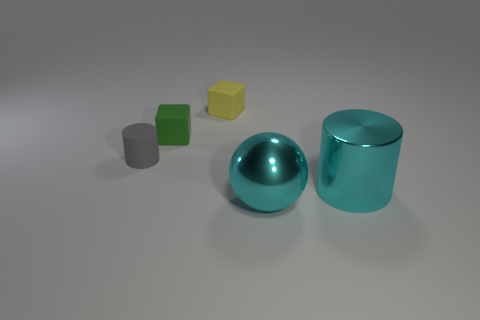Add 3 small cyan metallic objects. How many objects exist? 8 Subtract all cubes. How many objects are left? 3 Add 3 yellow blocks. How many yellow blocks exist? 4 Subtract 0 gray cubes. How many objects are left? 5 Subtract all tiny yellow matte cubes. Subtract all large purple cylinders. How many objects are left? 4 Add 1 big things. How many big things are left? 3 